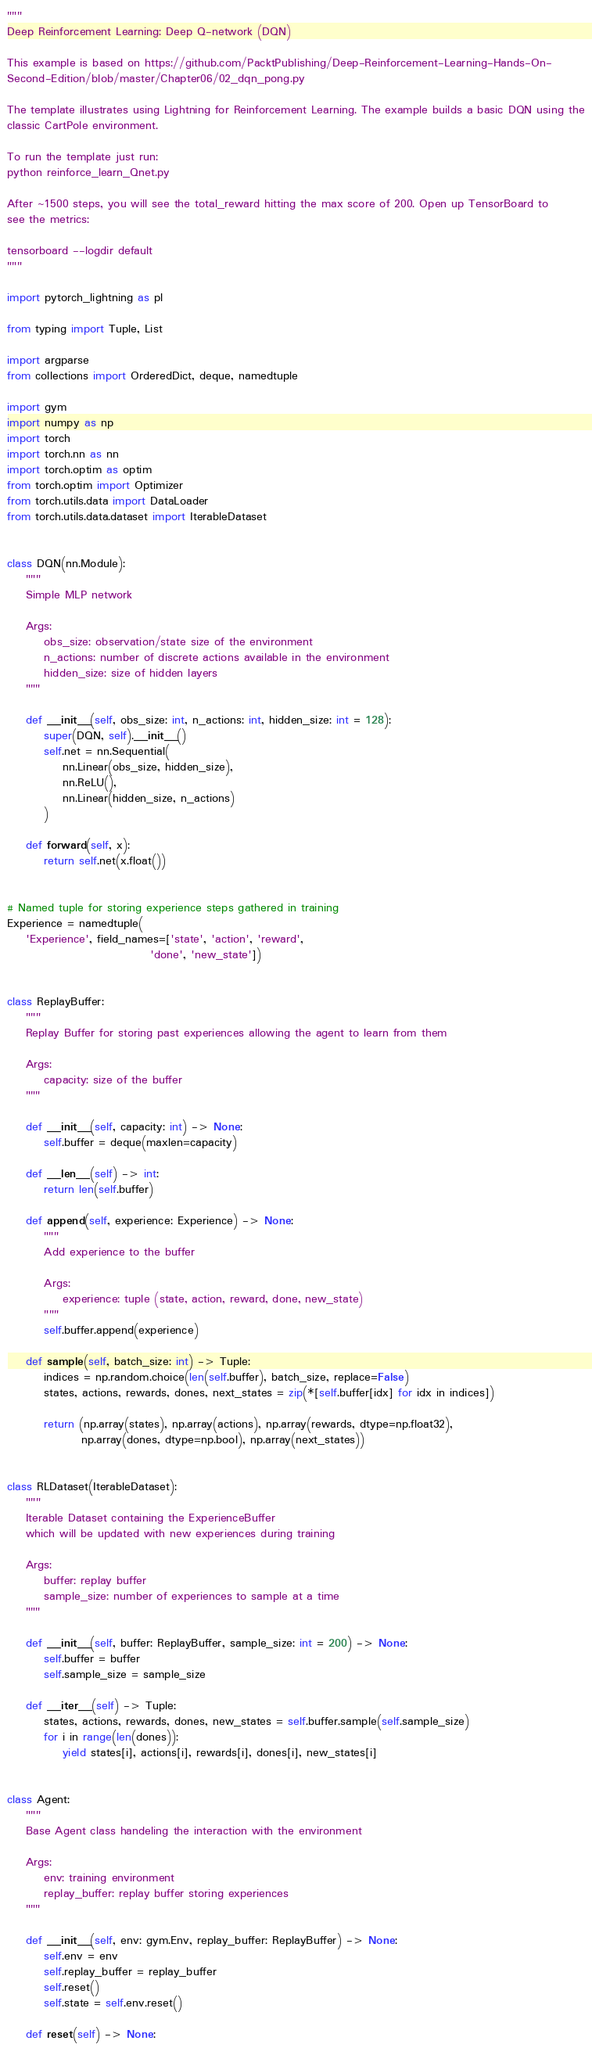Convert code to text. <code><loc_0><loc_0><loc_500><loc_500><_Python_>"""
Deep Reinforcement Learning: Deep Q-network (DQN)

This example is based on https://github.com/PacktPublishing/Deep-Reinforcement-Learning-Hands-On-
Second-Edition/blob/master/Chapter06/02_dqn_pong.py

The template illustrates using Lightning for Reinforcement Learning. The example builds a basic DQN using the
classic CartPole environment.

To run the template just run:
python reinforce_learn_Qnet.py

After ~1500 steps, you will see the total_reward hitting the max score of 200. Open up TensorBoard to
see the metrics:

tensorboard --logdir default
"""

import pytorch_lightning as pl

from typing import Tuple, List

import argparse
from collections import OrderedDict, deque, namedtuple

import gym
import numpy as np
import torch
import torch.nn as nn
import torch.optim as optim
from torch.optim import Optimizer
from torch.utils.data import DataLoader
from torch.utils.data.dataset import IterableDataset


class DQN(nn.Module):
    """
    Simple MLP network

    Args:
        obs_size: observation/state size of the environment
        n_actions: number of discrete actions available in the environment
        hidden_size: size of hidden layers
    """

    def __init__(self, obs_size: int, n_actions: int, hidden_size: int = 128):
        super(DQN, self).__init__()
        self.net = nn.Sequential(
            nn.Linear(obs_size, hidden_size),
            nn.ReLU(),
            nn.Linear(hidden_size, n_actions)
        )

    def forward(self, x):
        return self.net(x.float())


# Named tuple for storing experience steps gathered in training
Experience = namedtuple(
    'Experience', field_names=['state', 'action', 'reward',
                               'done', 'new_state'])


class ReplayBuffer:
    """
    Replay Buffer for storing past experiences allowing the agent to learn from them

    Args:
        capacity: size of the buffer
    """

    def __init__(self, capacity: int) -> None:
        self.buffer = deque(maxlen=capacity)

    def __len__(self) -> int:
        return len(self.buffer)

    def append(self, experience: Experience) -> None:
        """
        Add experience to the buffer

        Args:
            experience: tuple (state, action, reward, done, new_state)
        """
        self.buffer.append(experience)

    def sample(self, batch_size: int) -> Tuple:
        indices = np.random.choice(len(self.buffer), batch_size, replace=False)
        states, actions, rewards, dones, next_states = zip(*[self.buffer[idx] for idx in indices])

        return (np.array(states), np.array(actions), np.array(rewards, dtype=np.float32),
                np.array(dones, dtype=np.bool), np.array(next_states))


class RLDataset(IterableDataset):
    """
    Iterable Dataset containing the ExperienceBuffer
    which will be updated with new experiences during training

    Args:
        buffer: replay buffer
        sample_size: number of experiences to sample at a time
    """

    def __init__(self, buffer: ReplayBuffer, sample_size: int = 200) -> None:
        self.buffer = buffer
        self.sample_size = sample_size

    def __iter__(self) -> Tuple:
        states, actions, rewards, dones, new_states = self.buffer.sample(self.sample_size)
        for i in range(len(dones)):
            yield states[i], actions[i], rewards[i], dones[i], new_states[i]


class Agent:
    """
    Base Agent class handeling the interaction with the environment

    Args:
        env: training environment
        replay_buffer: replay buffer storing experiences
    """

    def __init__(self, env: gym.Env, replay_buffer: ReplayBuffer) -> None:
        self.env = env
        self.replay_buffer = replay_buffer
        self.reset()
        self.state = self.env.reset()

    def reset(self) -> None:</code> 